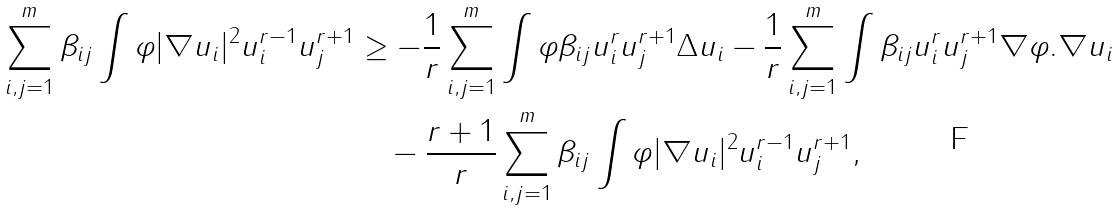<formula> <loc_0><loc_0><loc_500><loc_500>\sum _ { i , j = 1 } ^ { m } \beta _ { i j } \int \varphi | \nabla u _ { i } | ^ { 2 } u _ { i } ^ { r - 1 } u _ { j } ^ { r + 1 } & \geq - \frac { 1 } { r } \sum _ { i , j = 1 } ^ { m } \int \varphi \beta _ { i j } u _ { i } ^ { r } u _ { j } ^ { r + 1 } \Delta u _ { i } - \frac { 1 } { r } \sum _ { i , j = 1 } ^ { m } \int \beta _ { i j } u _ { i } ^ { r } u _ { j } ^ { r + 1 } \nabla \varphi . \nabla u _ { i } \\ & \quad - \frac { r + 1 } { r } \sum _ { i , j = 1 } ^ { m } \beta _ { i j } \int \varphi | \nabla u _ { i } | ^ { 2 } u _ { i } ^ { r - 1 } u _ { j } ^ { r + 1 } ,</formula> 